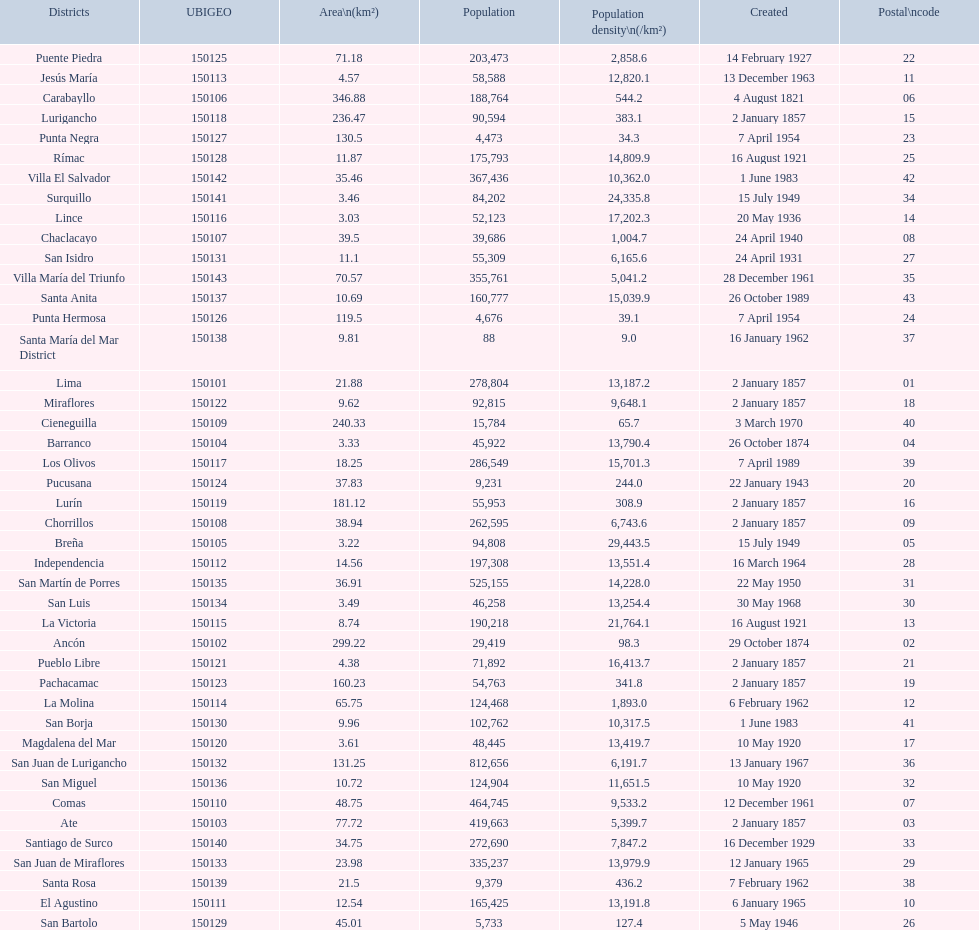How many districts are there in this city? 43. 